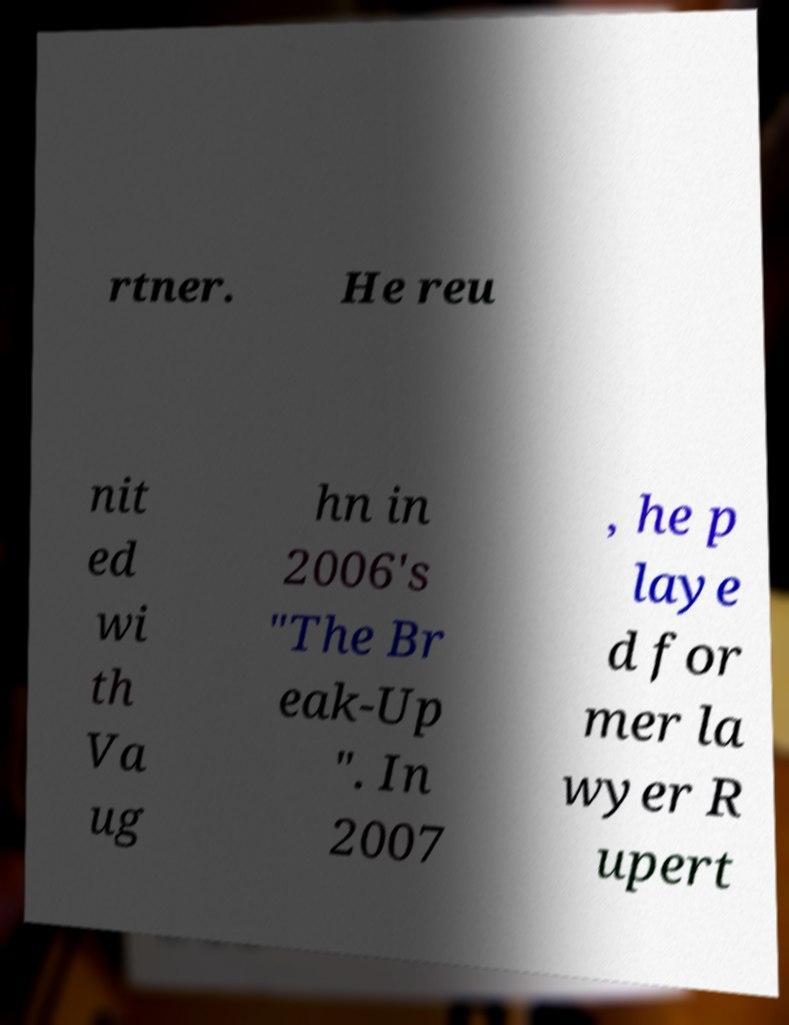Can you accurately transcribe the text from the provided image for me? rtner. He reu nit ed wi th Va ug hn in 2006's "The Br eak-Up ". In 2007 , he p laye d for mer la wyer R upert 